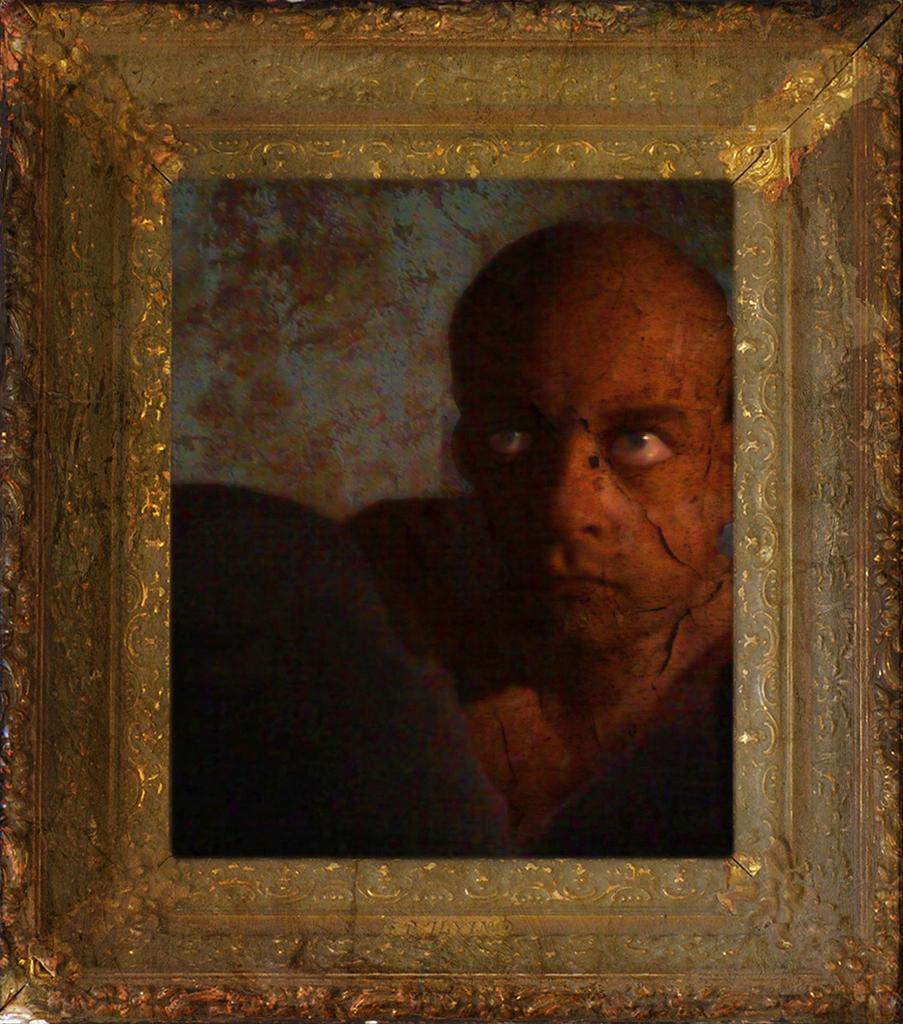Please provide a concise description of this image. The picture consists of a frame, in the frame we can see a person's photograph. 